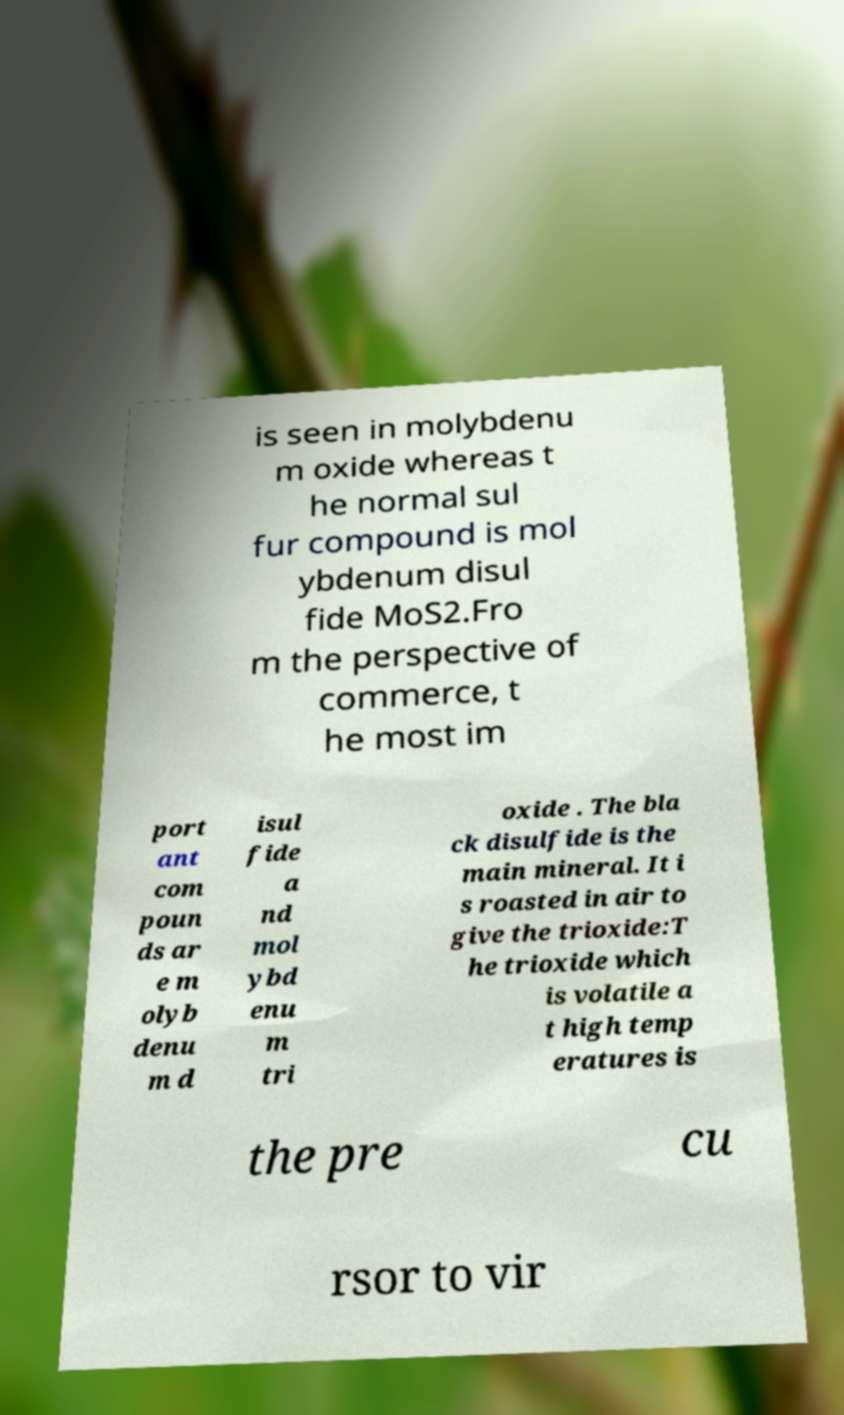Can you read and provide the text displayed in the image?This photo seems to have some interesting text. Can you extract and type it out for me? is seen in molybdenu m oxide whereas t he normal sul fur compound is mol ybdenum disul fide MoS2.Fro m the perspective of commerce, t he most im port ant com poun ds ar e m olyb denu m d isul fide a nd mol ybd enu m tri oxide . The bla ck disulfide is the main mineral. It i s roasted in air to give the trioxide:T he trioxide which is volatile a t high temp eratures is the pre cu rsor to vir 